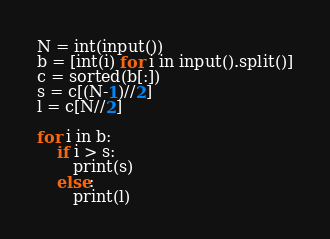Convert code to text. <code><loc_0><loc_0><loc_500><loc_500><_Python_>N = int(input())
b = [int(i) for i in input().split()]
c = sorted(b[:])
s = c[(N-1)//2]
l = c[N//2]

for i in b:
    if i > s:
       print(s)
    else:
       print(l)</code> 